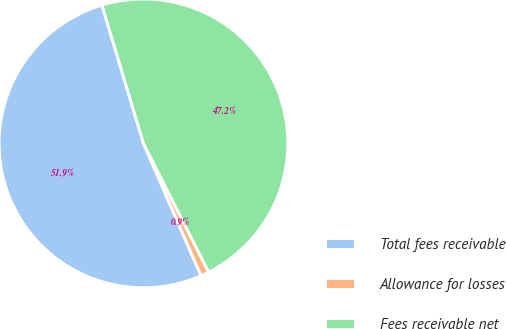Convert chart. <chart><loc_0><loc_0><loc_500><loc_500><pie_chart><fcel>Total fees receivable<fcel>Allowance for losses<fcel>Fees receivable net<nl><fcel>51.89%<fcel>0.93%<fcel>47.18%<nl></chart> 